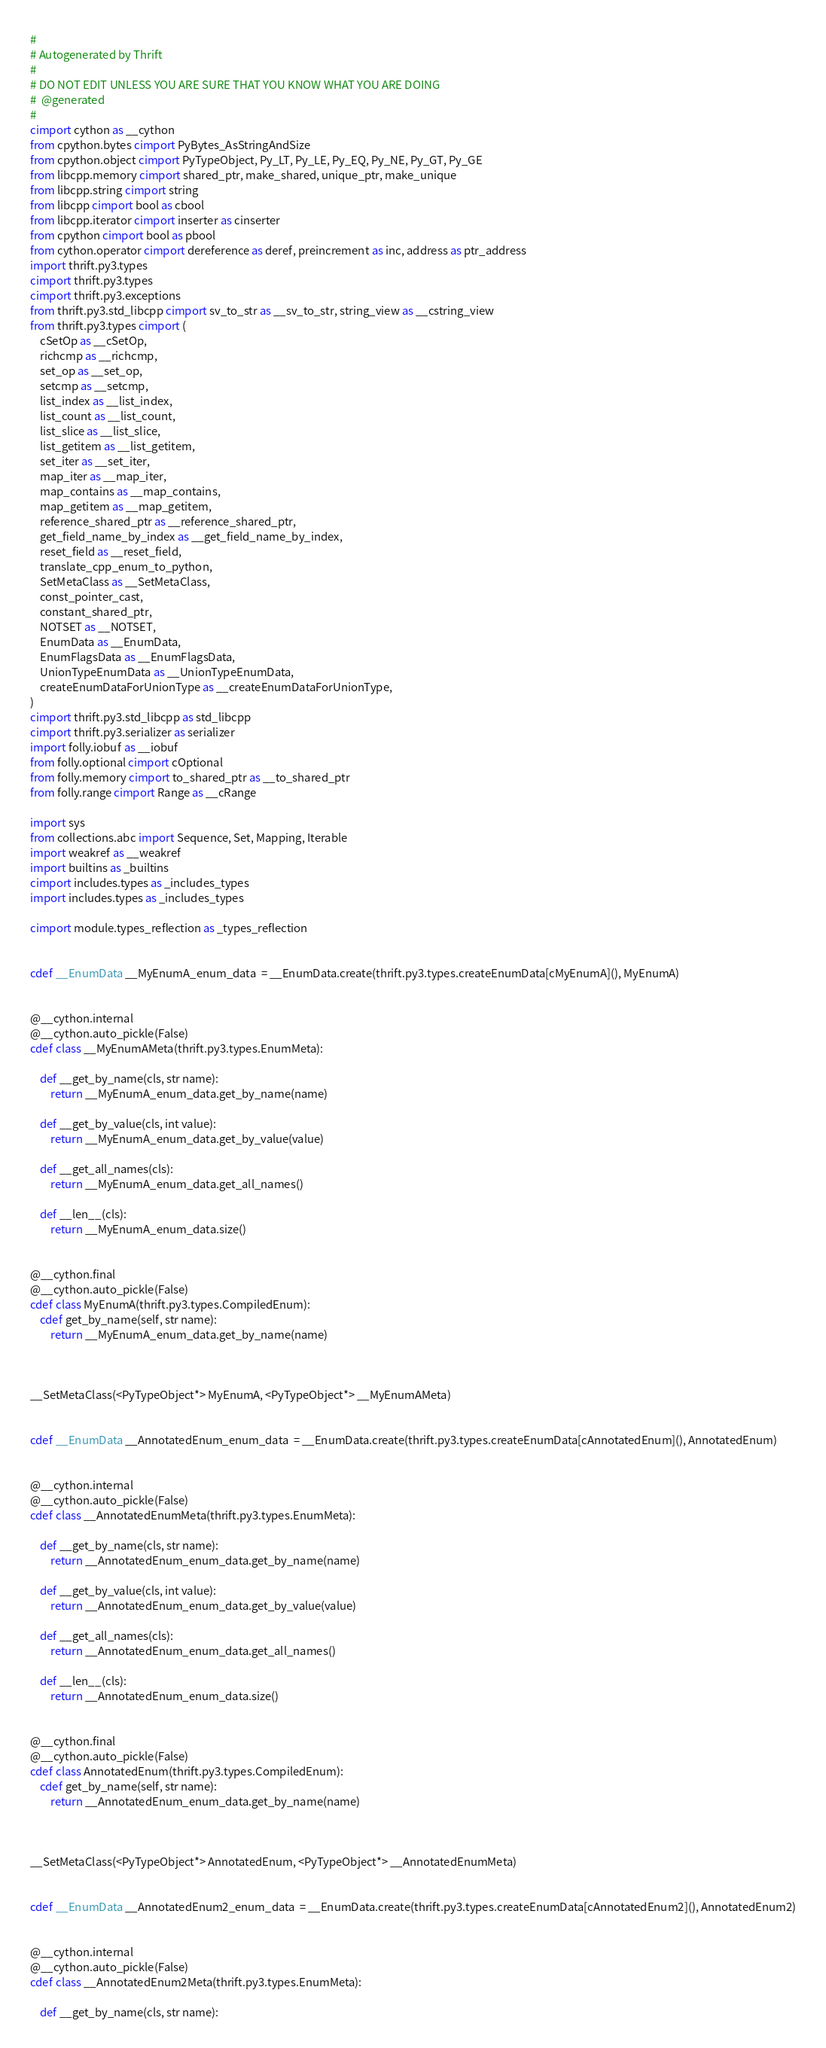<code> <loc_0><loc_0><loc_500><loc_500><_Cython_>#
# Autogenerated by Thrift
#
# DO NOT EDIT UNLESS YOU ARE SURE THAT YOU KNOW WHAT YOU ARE DOING
#  @generated
#
cimport cython as __cython
from cpython.bytes cimport PyBytes_AsStringAndSize
from cpython.object cimport PyTypeObject, Py_LT, Py_LE, Py_EQ, Py_NE, Py_GT, Py_GE
from libcpp.memory cimport shared_ptr, make_shared, unique_ptr, make_unique
from libcpp.string cimport string
from libcpp cimport bool as cbool
from libcpp.iterator cimport inserter as cinserter
from cpython cimport bool as pbool
from cython.operator cimport dereference as deref, preincrement as inc, address as ptr_address
import thrift.py3.types
cimport thrift.py3.types
cimport thrift.py3.exceptions
from thrift.py3.std_libcpp cimport sv_to_str as __sv_to_str, string_view as __cstring_view
from thrift.py3.types cimport (
    cSetOp as __cSetOp,
    richcmp as __richcmp,
    set_op as __set_op,
    setcmp as __setcmp,
    list_index as __list_index,
    list_count as __list_count,
    list_slice as __list_slice,
    list_getitem as __list_getitem,
    set_iter as __set_iter,
    map_iter as __map_iter,
    map_contains as __map_contains,
    map_getitem as __map_getitem,
    reference_shared_ptr as __reference_shared_ptr,
    get_field_name_by_index as __get_field_name_by_index,
    reset_field as __reset_field,
    translate_cpp_enum_to_python,
    SetMetaClass as __SetMetaClass,
    const_pointer_cast,
    constant_shared_ptr,
    NOTSET as __NOTSET,
    EnumData as __EnumData,
    EnumFlagsData as __EnumFlagsData,
    UnionTypeEnumData as __UnionTypeEnumData,
    createEnumDataForUnionType as __createEnumDataForUnionType,
)
cimport thrift.py3.std_libcpp as std_libcpp
cimport thrift.py3.serializer as serializer
import folly.iobuf as __iobuf
from folly.optional cimport cOptional
from folly.memory cimport to_shared_ptr as __to_shared_ptr
from folly.range cimport Range as __cRange

import sys
from collections.abc import Sequence, Set, Mapping, Iterable
import weakref as __weakref
import builtins as _builtins
cimport includes.types as _includes_types
import includes.types as _includes_types

cimport module.types_reflection as _types_reflection


cdef __EnumData __MyEnumA_enum_data  = __EnumData.create(thrift.py3.types.createEnumData[cMyEnumA](), MyEnumA)


@__cython.internal
@__cython.auto_pickle(False)
cdef class __MyEnumAMeta(thrift.py3.types.EnumMeta):

    def __get_by_name(cls, str name):
        return __MyEnumA_enum_data.get_by_name(name)

    def __get_by_value(cls, int value):
        return __MyEnumA_enum_data.get_by_value(value)

    def __get_all_names(cls):
        return __MyEnumA_enum_data.get_all_names()

    def __len__(cls):
        return __MyEnumA_enum_data.size()


@__cython.final
@__cython.auto_pickle(False)
cdef class MyEnumA(thrift.py3.types.CompiledEnum):
    cdef get_by_name(self, str name):
        return __MyEnumA_enum_data.get_by_name(name)



__SetMetaClass(<PyTypeObject*> MyEnumA, <PyTypeObject*> __MyEnumAMeta)


cdef __EnumData __AnnotatedEnum_enum_data  = __EnumData.create(thrift.py3.types.createEnumData[cAnnotatedEnum](), AnnotatedEnum)


@__cython.internal
@__cython.auto_pickle(False)
cdef class __AnnotatedEnumMeta(thrift.py3.types.EnumMeta):

    def __get_by_name(cls, str name):
        return __AnnotatedEnum_enum_data.get_by_name(name)

    def __get_by_value(cls, int value):
        return __AnnotatedEnum_enum_data.get_by_value(value)

    def __get_all_names(cls):
        return __AnnotatedEnum_enum_data.get_all_names()

    def __len__(cls):
        return __AnnotatedEnum_enum_data.size()


@__cython.final
@__cython.auto_pickle(False)
cdef class AnnotatedEnum(thrift.py3.types.CompiledEnum):
    cdef get_by_name(self, str name):
        return __AnnotatedEnum_enum_data.get_by_name(name)



__SetMetaClass(<PyTypeObject*> AnnotatedEnum, <PyTypeObject*> __AnnotatedEnumMeta)


cdef __EnumData __AnnotatedEnum2_enum_data  = __EnumData.create(thrift.py3.types.createEnumData[cAnnotatedEnum2](), AnnotatedEnum2)


@__cython.internal
@__cython.auto_pickle(False)
cdef class __AnnotatedEnum2Meta(thrift.py3.types.EnumMeta):

    def __get_by_name(cls, str name):</code> 